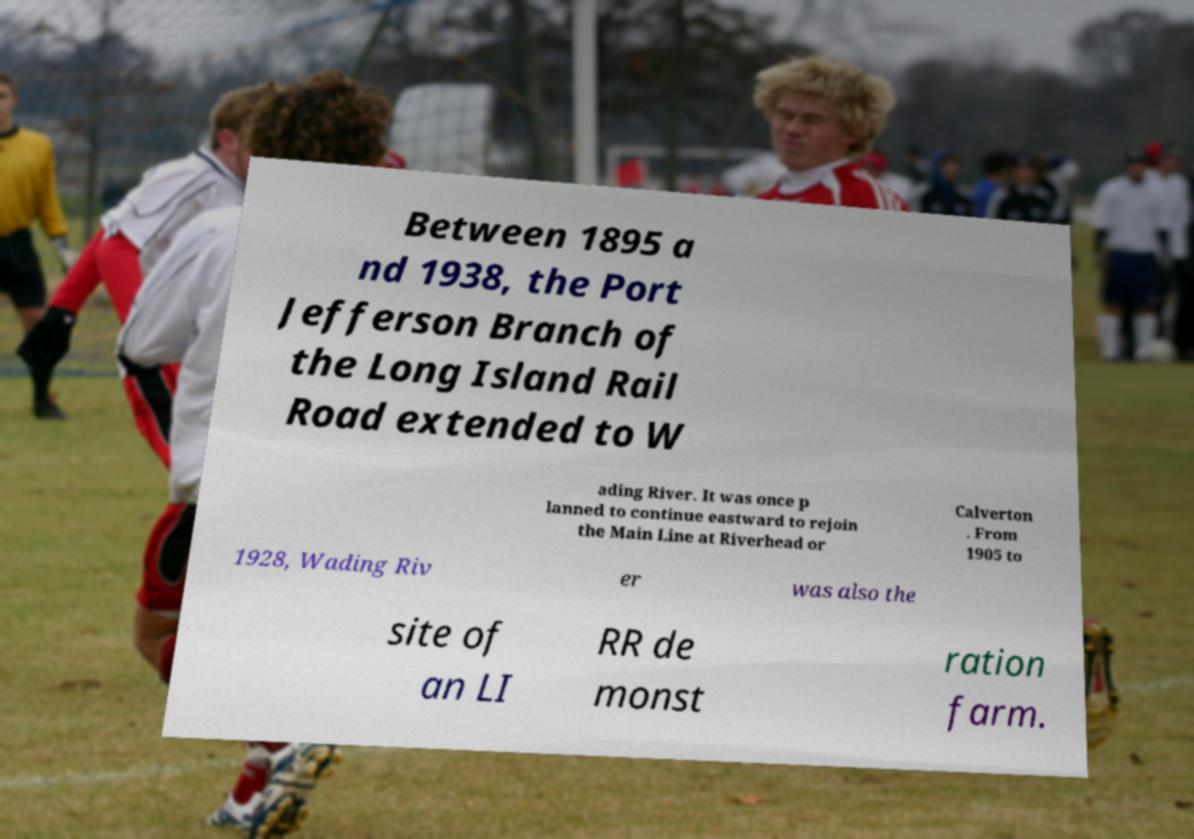Could you assist in decoding the text presented in this image and type it out clearly? Between 1895 a nd 1938, the Port Jefferson Branch of the Long Island Rail Road extended to W ading River. It was once p lanned to continue eastward to rejoin the Main Line at Riverhead or Calverton . From 1905 to 1928, Wading Riv er was also the site of an LI RR de monst ration farm. 